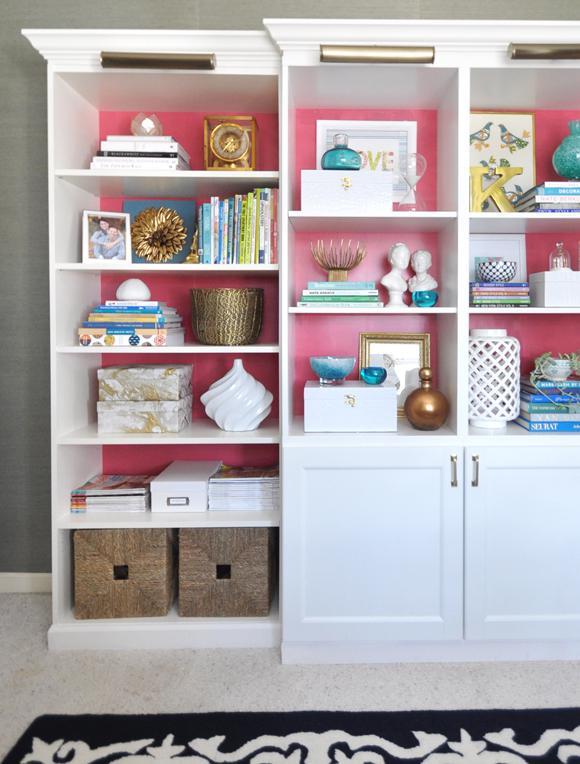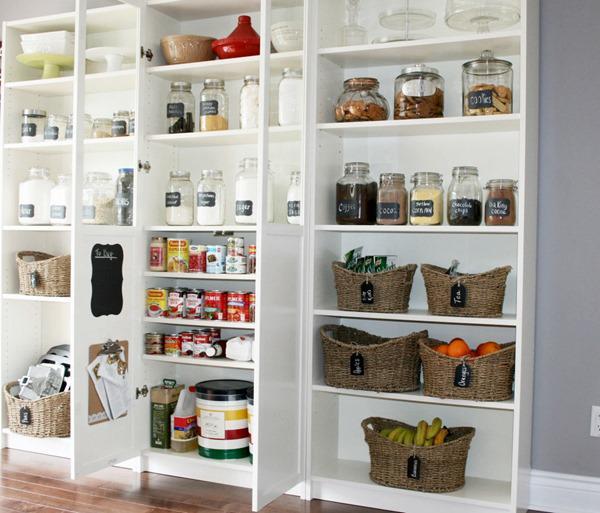The first image is the image on the left, the second image is the image on the right. For the images displayed, is the sentence "There is one big white bookshelf, with pink back panels and two wicker basket on the bottle left shelf." factually correct? Answer yes or no. Yes. 